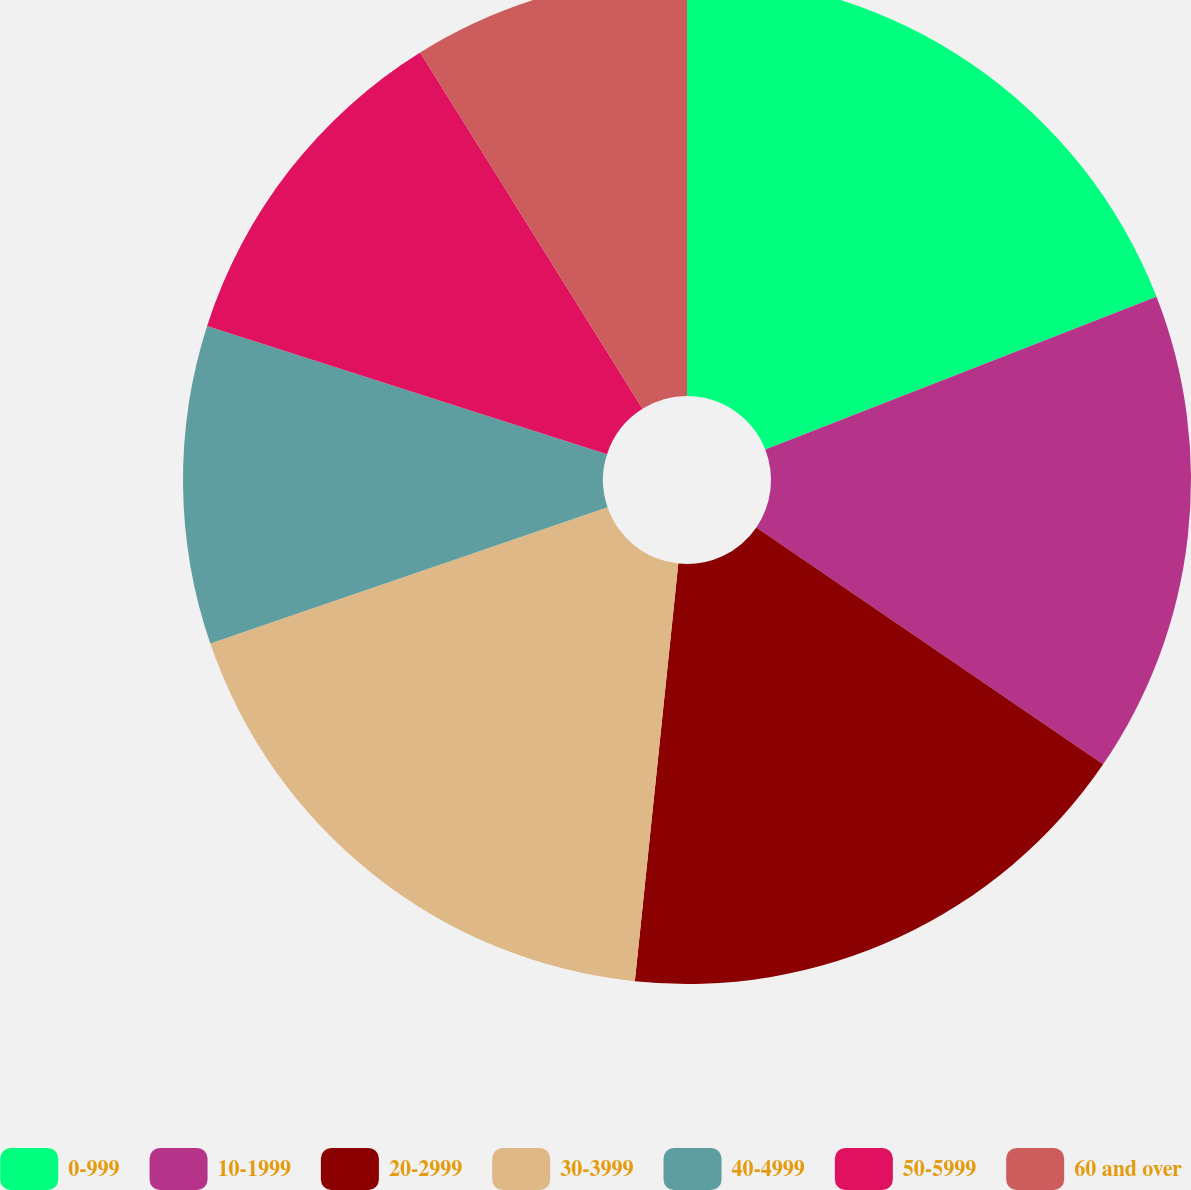Convert chart to OTSL. <chart><loc_0><loc_0><loc_500><loc_500><pie_chart><fcel>0-999<fcel>10-1999<fcel>20-2999<fcel>30-3999<fcel>40-4999<fcel>50-5999<fcel>60 and over<nl><fcel>19.08%<fcel>15.46%<fcel>17.11%<fcel>18.09%<fcel>10.2%<fcel>11.18%<fcel>8.88%<nl></chart> 